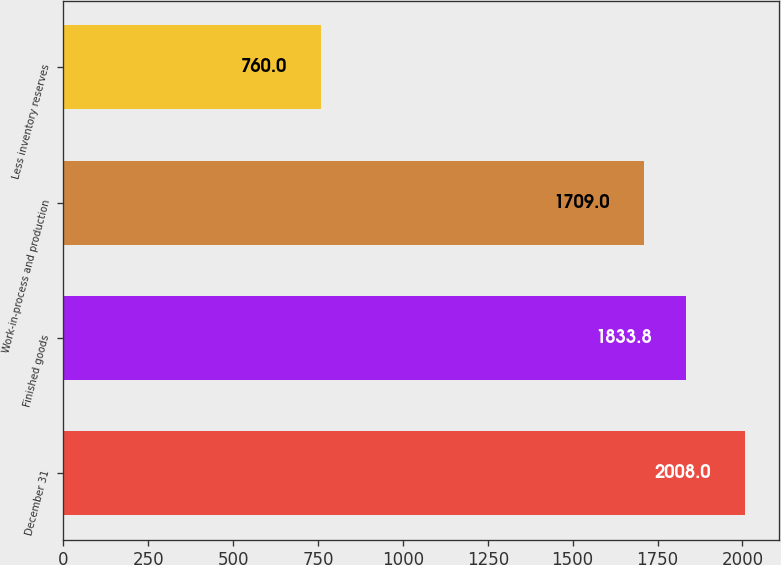<chart> <loc_0><loc_0><loc_500><loc_500><bar_chart><fcel>December 31<fcel>Finished goods<fcel>Work-in-process and production<fcel>Less inventory reserves<nl><fcel>2008<fcel>1833.8<fcel>1709<fcel>760<nl></chart> 